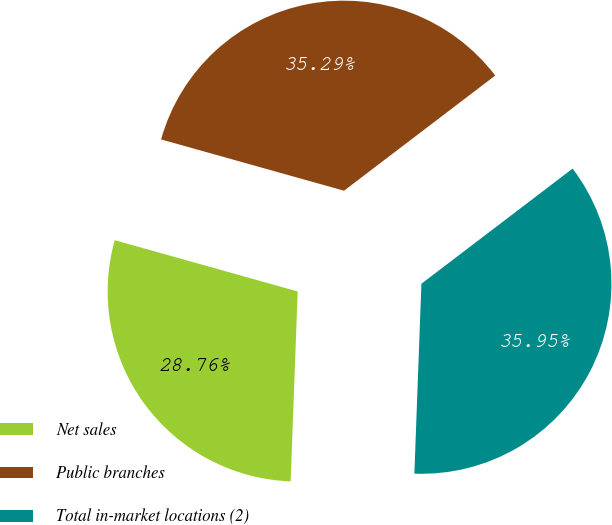<chart> <loc_0><loc_0><loc_500><loc_500><pie_chart><fcel>Net sales<fcel>Public branches<fcel>Total in-market locations (2)<nl><fcel>28.76%<fcel>35.29%<fcel>35.95%<nl></chart> 